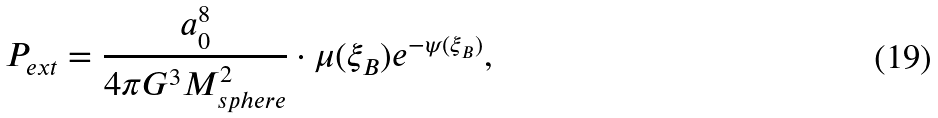Convert formula to latex. <formula><loc_0><loc_0><loc_500><loc_500>P _ { e x t } = \frac { a ^ { 8 } _ { 0 } } { 4 \pi G ^ { 3 } M ^ { 2 } _ { s p h e r e } } \cdot \mu ( \xi _ { B } ) e ^ { - \psi ( \xi _ { B } ) } ,</formula> 